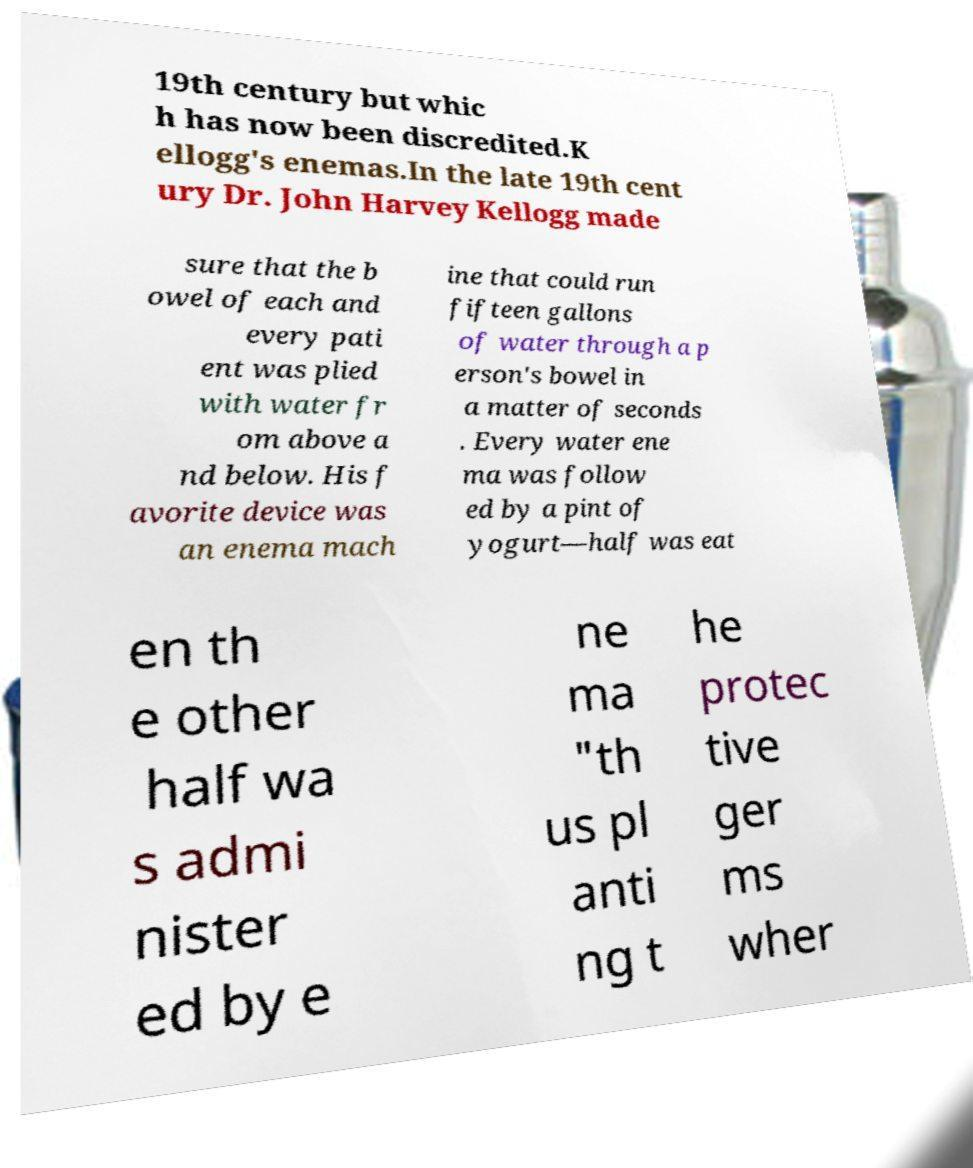Can you read and provide the text displayed in the image?This photo seems to have some interesting text. Can you extract and type it out for me? 19th century but whic h has now been discredited.K ellogg's enemas.In the late 19th cent ury Dr. John Harvey Kellogg made sure that the b owel of each and every pati ent was plied with water fr om above a nd below. His f avorite device was an enema mach ine that could run fifteen gallons of water through a p erson's bowel in a matter of seconds . Every water ene ma was follow ed by a pint of yogurt—half was eat en th e other half wa s admi nister ed by e ne ma "th us pl anti ng t he protec tive ger ms wher 